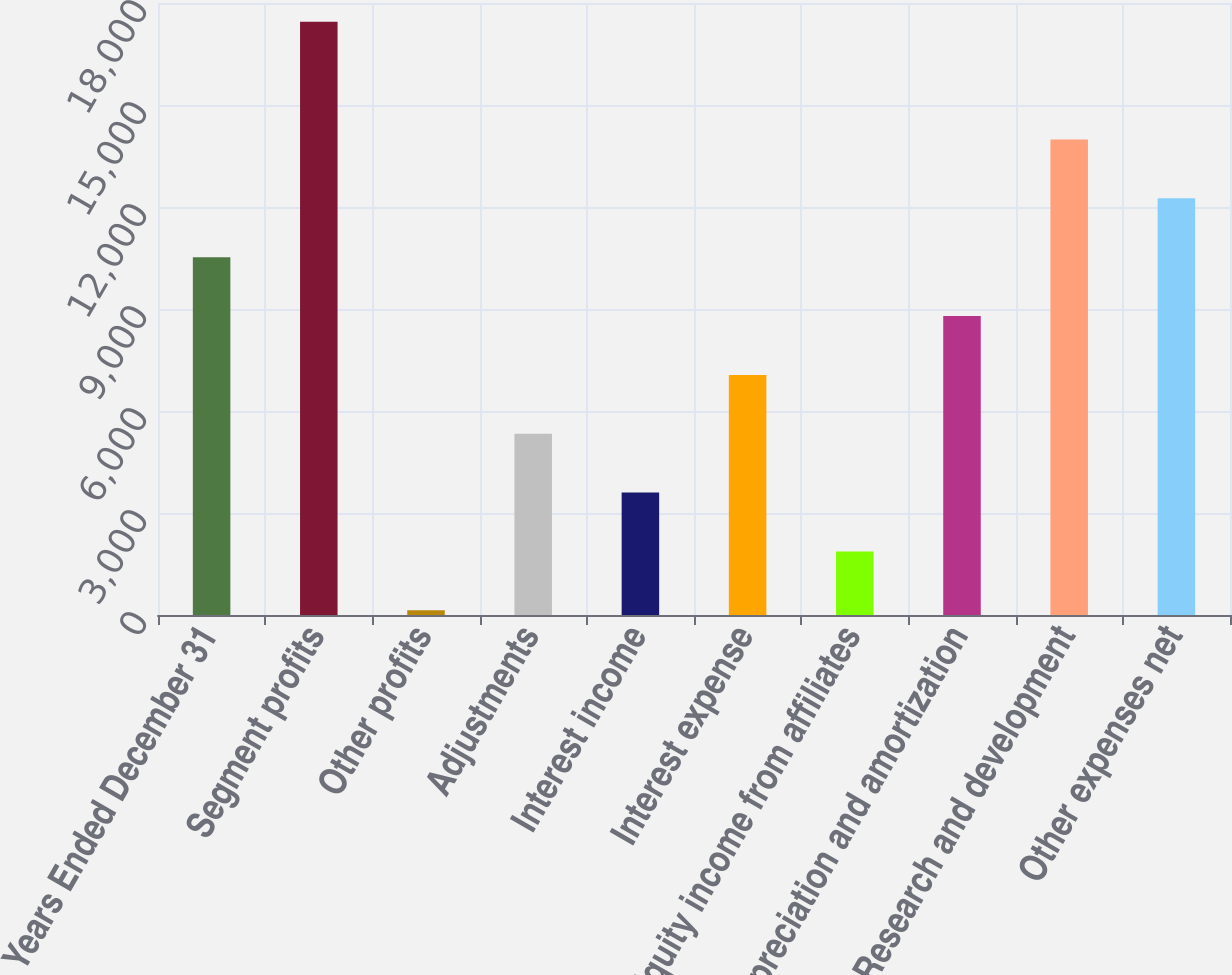<chart> <loc_0><loc_0><loc_500><loc_500><bar_chart><fcel>Years Ended December 31<fcel>Segment profits<fcel>Other profits<fcel>Adjustments<fcel>Interest income<fcel>Interest expense<fcel>Equity income from affiliates<fcel>Depreciation and amortization<fcel>Research and development<fcel>Other expenses net<nl><fcel>10524.5<fcel>17449.7<fcel>136.7<fcel>5330.6<fcel>3599.3<fcel>7061.9<fcel>1868<fcel>8793.2<fcel>13987.1<fcel>12255.8<nl></chart> 